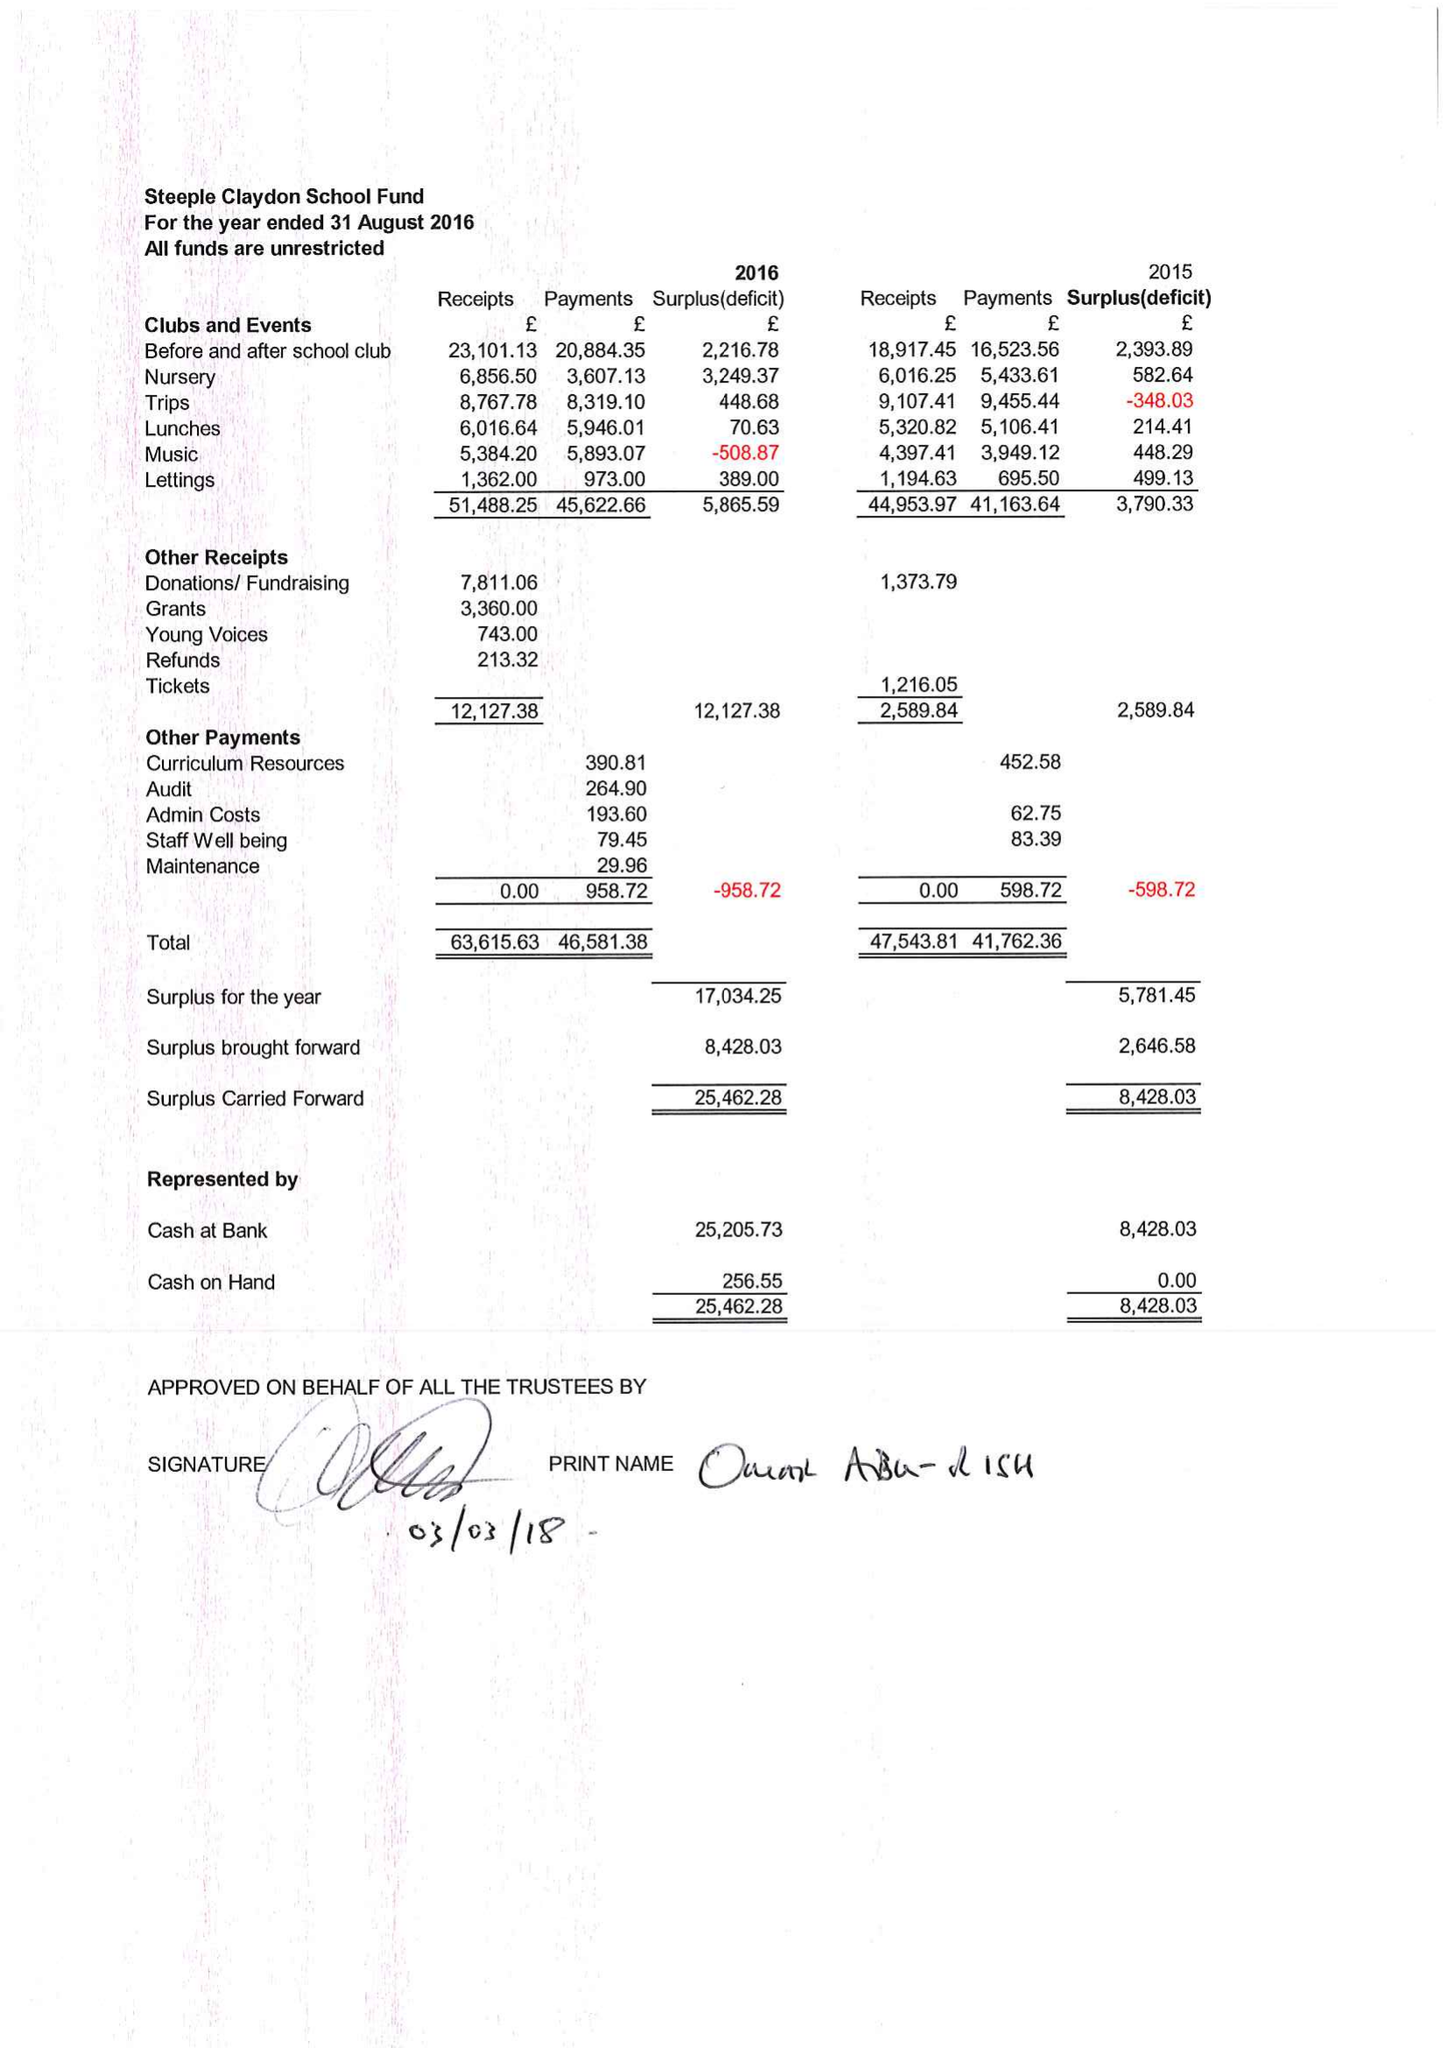What is the value for the address__street_line?
Answer the question using a single word or phrase. MEADOWAY 